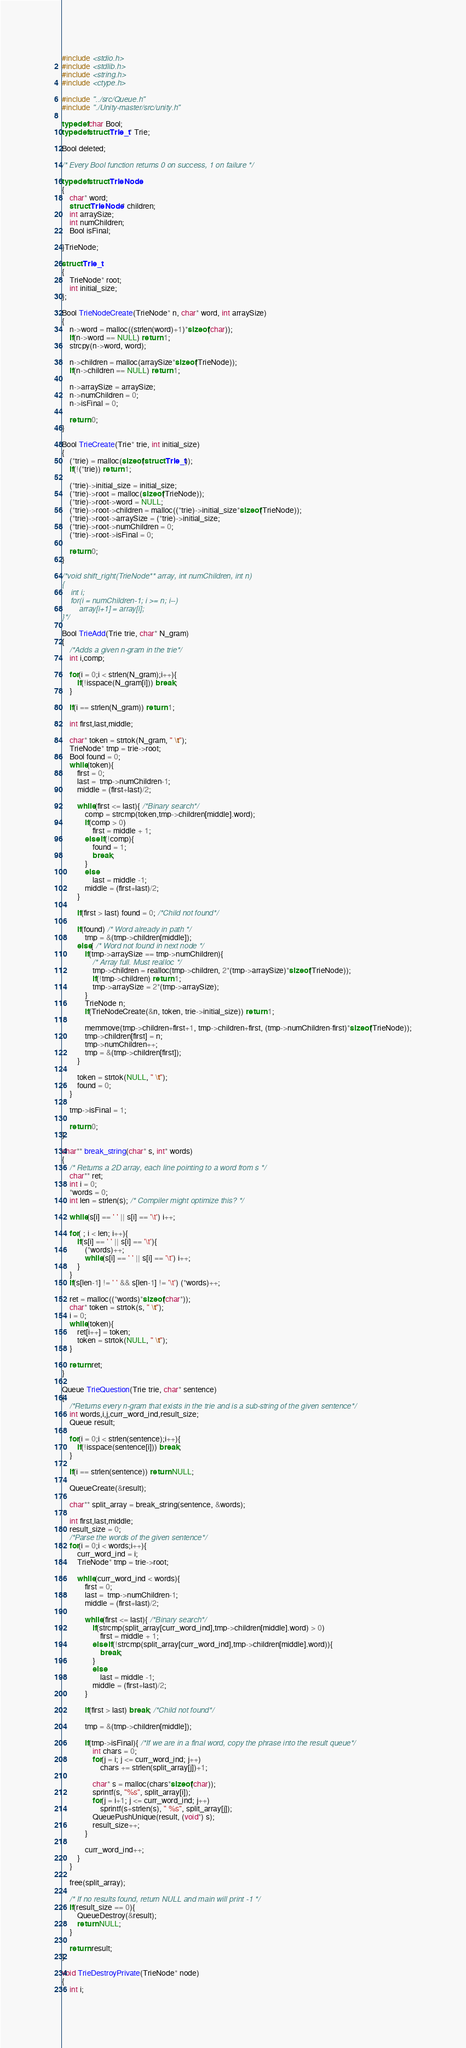Convert code to text. <code><loc_0><loc_0><loc_500><loc_500><_C_>#include <stdio.h>
#include <stdlib.h>
#include <string.h>
#include <ctype.h>

#include "../src/Queue.h"
#include "./Unity-master/src/unity.h"

typedef char Bool;
typedef struct Trie_t* Trie;

Bool deleted;

/* Every Bool function returns 0 on success, 1 on failure */

typedef struct TrieNode
{
	char* word;
	struct TrieNode* children;
	int arraySize;
	int numChildren;
	Bool isFinal;

}TrieNode;

struct Trie_t
{
	TrieNode* root;
	int initial_size;
};

Bool TrieNodeCreate(TrieNode* n, char* word, int arraySize)
{
	n->word = malloc((strlen(word)+1)*sizeof(char));
	if(n->word == NULL) return 1;
	strcpy(n->word, word);
	
	n->children = malloc(arraySize*sizeof(TrieNode));
	if(n->children == NULL) return 1;
	
	n->arraySize = arraySize;
	n->numChildren = 0;
	n->isFinal = 0;

	return 0;
}

Bool TrieCreate(Trie* trie, int initial_size)
{
	(*trie) = malloc(sizeof(struct Trie_t));
	if(!(*trie)) return 1;

	(*trie)->initial_size = initial_size;
	(*trie)->root = malloc(sizeof(TrieNode));
	(*trie)->root->word = NULL;
	(*trie)->root->children = malloc((*trie)->initial_size*sizeof(TrieNode));
	(*trie)->root->arraySize = (*trie)->initial_size;
	(*trie)->root->numChildren = 0;
	(*trie)->root->isFinal = 0;

	return 0;
}

/*void shift_right(TrieNode** array, int numChildren, int n)
{
	int i;
	for(i = numChildren-1; i >= n; i--)
		array[i+1] = array[i];
}*/

Bool TrieAdd(Trie trie, char* N_gram)
{
	/*Adds a given n-gram in the trie*/
	int i,comp;

	for(i = 0;i < strlen(N_gram);i++){
		if(!isspace(N_gram[i])) break;
	}

	if(i == strlen(N_gram)) return 1;

	int first,last,middle;

	char* token = strtok(N_gram, " \t");
	TrieNode* tmp = trie->root;
	Bool found = 0;
	while(token){
		first = 0;
		last =  tmp->numChildren-1;
		middle = (first+last)/2;

		while(first <= last){ /*Binary search*/
			comp = strcmp(token,tmp->children[middle].word);
			if(comp > 0)
				first = middle + 1;
			else if(!comp){
				found = 1;
				break;
			}
			else 
				last = middle -1;
			middle = (first+last)/2;
		}

		if(first > last) found = 0; /*Child not found*/

		if(found) /* Word already in path */
			tmp = &(tmp->children[middle]);
		else{ /* Word not found in next node */
			if(tmp->arraySize == tmp->numChildren){
				/* Array full. Must realloc */
				tmp->children = realloc(tmp->children, 2*(tmp->arraySize)*sizeof(TrieNode));
				if(!tmp->children) return 1;
				tmp->arraySize = 2*(tmp->arraySize);
			}
			TrieNode n;
			if(TrieNodeCreate(&n, token, trie->initial_size)) return 1;

			memmove(tmp->children+first+1, tmp->children+first, (tmp->numChildren-first)*sizeof(TrieNode));
			tmp->children[first] = n;
			tmp->numChildren++;
			tmp = &(tmp->children[first]);
		}

    	token = strtok(NULL, " \t");
    	found = 0;
	}

	tmp->isFinal = 1;

	return 0;
}

char** break_string(char* s, int* words)
{
	/* Returns a 2D array, each line pointing to a word from s */
	char** ret;
	int i = 0;
	*words = 0;
	int len = strlen(s); /* Compiler might optimize this? */

	while(s[i] == ' ' || s[i] == '\t') i++;

	for( ; i < len; i++){
		if(s[i] == ' ' || s[i] == '\t'){
			(*words)++;
			while(s[i] == ' ' || s[i] == '\t') i++;
		}
	}
	if(s[len-1] != ' ' && s[len-1] != '\t') (*words)++;

	ret = malloc((*words)*sizeof(char*));
	char* token = strtok(s, " \t");
	i = 0;
	while(token){
		ret[i++] = token;
		token = strtok(NULL, " \t");
	}

	return ret;
}

Queue TrieQuestion(Trie trie, char* sentence)
{
	/*Returns every n-gram that exists in the trie and is a sub-string of the given sentence*/
	int words,i,j,curr_word_ind,result_size;
	Queue result;

	for(i = 0;i < strlen(sentence);i++){
		if(!isspace(sentence[i])) break;
	}

	if(i == strlen(sentence)) return NULL;

	QueueCreate(&result);

	char** split_array = break_string(sentence, &words);

	int first,last,middle;
	result_size = 0;
	/*Parse the words of the given sentence*/
	for(i = 0;i < words;i++){
		curr_word_ind = i;
		TrieNode* tmp = trie->root;

		while(curr_word_ind < words){
			first = 0;
			last =  tmp->numChildren-1;
			middle = (first+last)/2;
			
			while(first <= last){ /*Binary search*/
				if(strcmp(split_array[curr_word_ind],tmp->children[middle].word) > 0)
					first = middle + 1;
				else if(!strcmp(split_array[curr_word_ind],tmp->children[middle].word)){
					break;
				}
				else 
					last = middle -1;
				middle = (first+last)/2;
			}

			if(first > last) break; /*Child not found*/

			tmp = &(tmp->children[middle]);

			if(tmp->isFinal){ /*If we are in a final word, copy the phrase into the result queue*/
				int chars = 0;
				for(j = i; j <= curr_word_ind; j++)
					chars += strlen(split_array[j])+1;
				
				char* s = malloc(chars*sizeof(char));
				sprintf(s, "%s", split_array[i]);
				for(j = i+1; j <= curr_word_ind; j++)
					sprintf(s+strlen(s), " %s", split_array[j]);
				QueuePushUnique(result, (void*) s);
				result_size++;
			}

			curr_word_ind++;
		}
	}

	free(split_array);

	/* If no results found, return NULL and main will print -1 */
	if(result_size == 0){
		QueueDestroy(&result);
		return NULL;
	}

	return result; 
}

void TrieDestroyPrivate(TrieNode* node)
{
	int i;
</code> 